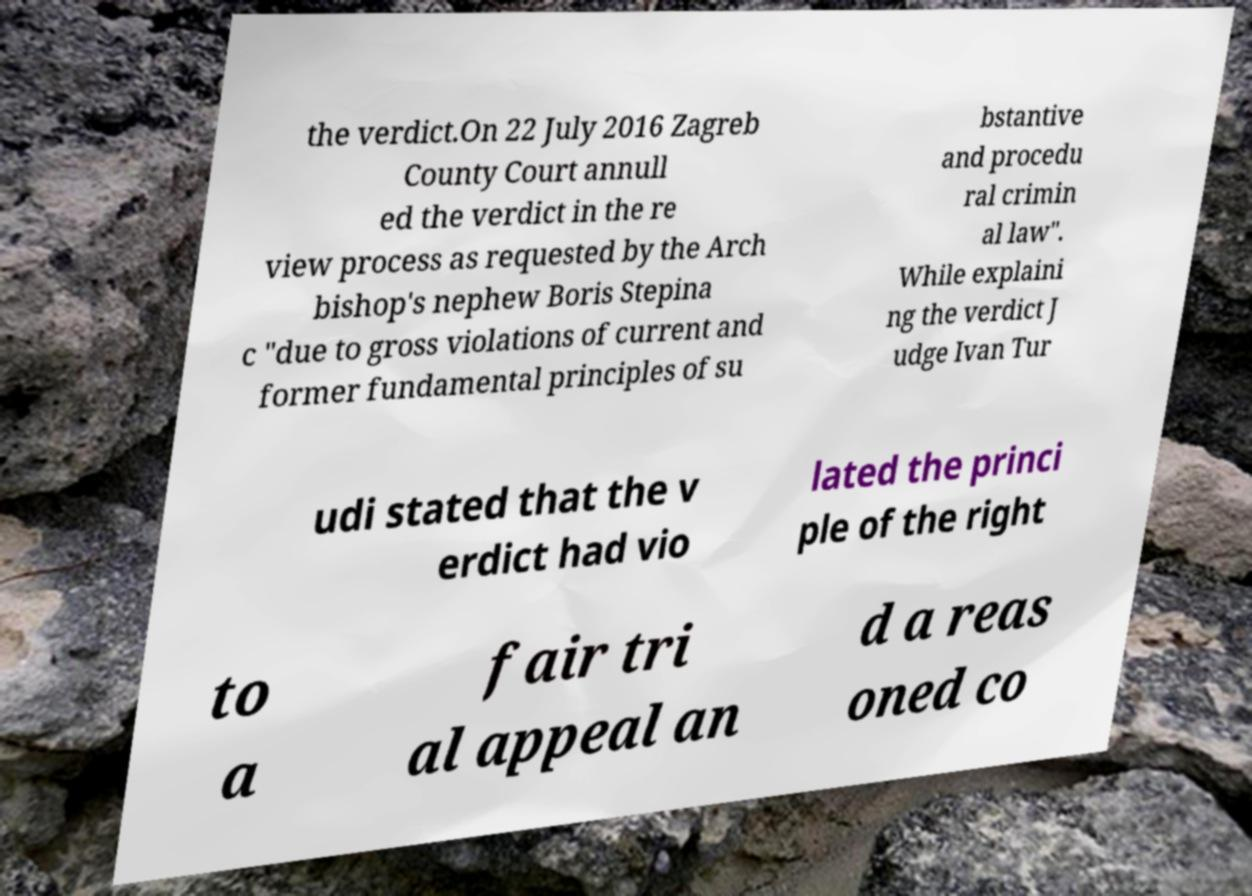I need the written content from this picture converted into text. Can you do that? the verdict.On 22 July 2016 Zagreb County Court annull ed the verdict in the re view process as requested by the Arch bishop's nephew Boris Stepina c "due to gross violations of current and former fundamental principles of su bstantive and procedu ral crimin al law". While explaini ng the verdict J udge Ivan Tur udi stated that the v erdict had vio lated the princi ple of the right to a fair tri al appeal an d a reas oned co 